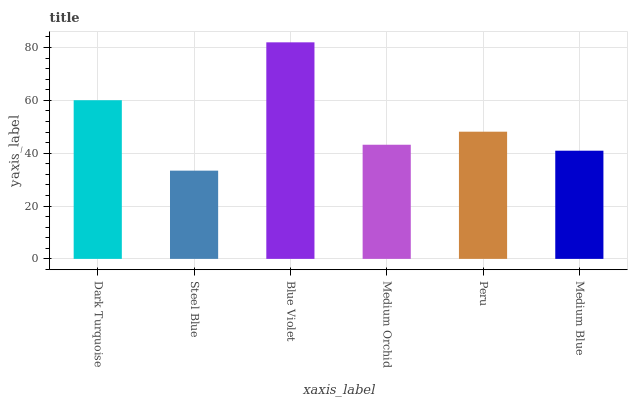Is Blue Violet the minimum?
Answer yes or no. No. Is Steel Blue the maximum?
Answer yes or no. No. Is Blue Violet greater than Steel Blue?
Answer yes or no. Yes. Is Steel Blue less than Blue Violet?
Answer yes or no. Yes. Is Steel Blue greater than Blue Violet?
Answer yes or no. No. Is Blue Violet less than Steel Blue?
Answer yes or no. No. Is Peru the high median?
Answer yes or no. Yes. Is Medium Orchid the low median?
Answer yes or no. Yes. Is Dark Turquoise the high median?
Answer yes or no. No. Is Peru the low median?
Answer yes or no. No. 